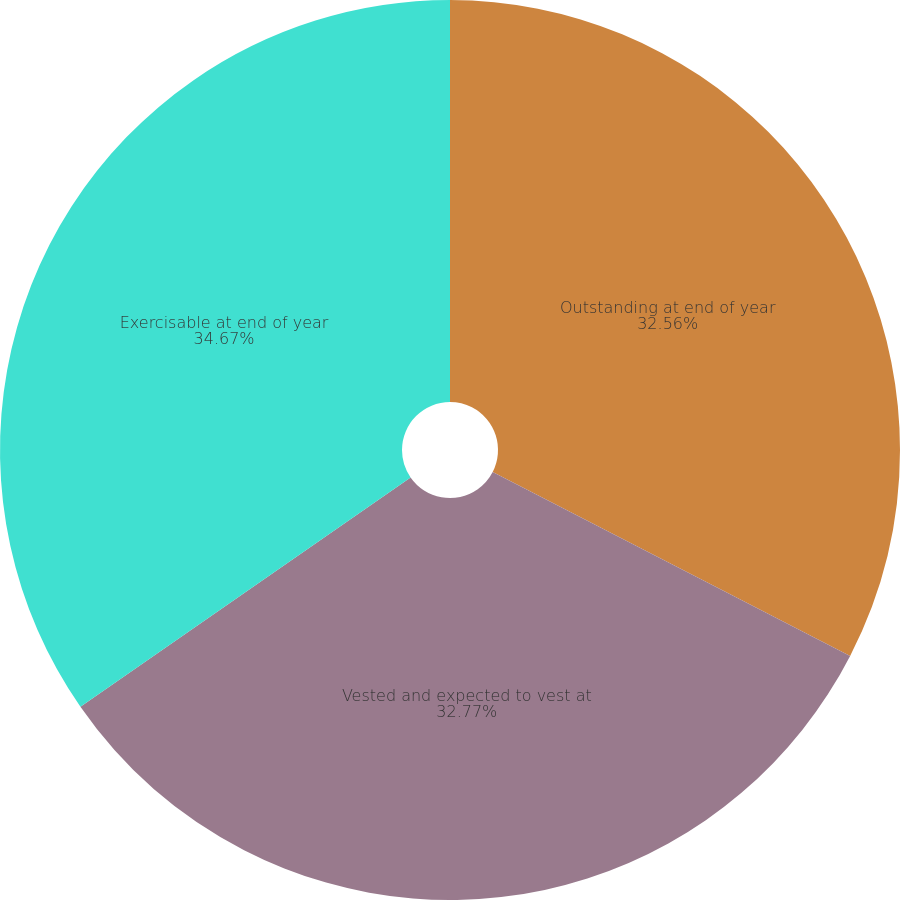<chart> <loc_0><loc_0><loc_500><loc_500><pie_chart><fcel>Outstanding at end of year<fcel>Vested and expected to vest at<fcel>Exercisable at end of year<nl><fcel>32.56%<fcel>32.77%<fcel>34.66%<nl></chart> 